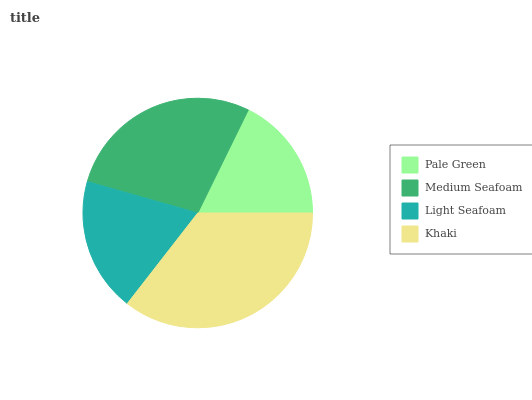Is Pale Green the minimum?
Answer yes or no. Yes. Is Khaki the maximum?
Answer yes or no. Yes. Is Medium Seafoam the minimum?
Answer yes or no. No. Is Medium Seafoam the maximum?
Answer yes or no. No. Is Medium Seafoam greater than Pale Green?
Answer yes or no. Yes. Is Pale Green less than Medium Seafoam?
Answer yes or no. Yes. Is Pale Green greater than Medium Seafoam?
Answer yes or no. No. Is Medium Seafoam less than Pale Green?
Answer yes or no. No. Is Medium Seafoam the high median?
Answer yes or no. Yes. Is Light Seafoam the low median?
Answer yes or no. Yes. Is Khaki the high median?
Answer yes or no. No. Is Pale Green the low median?
Answer yes or no. No. 